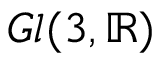<formula> <loc_0><loc_0><loc_500><loc_500>G l ( 3 , \mathbb { R } )</formula> 